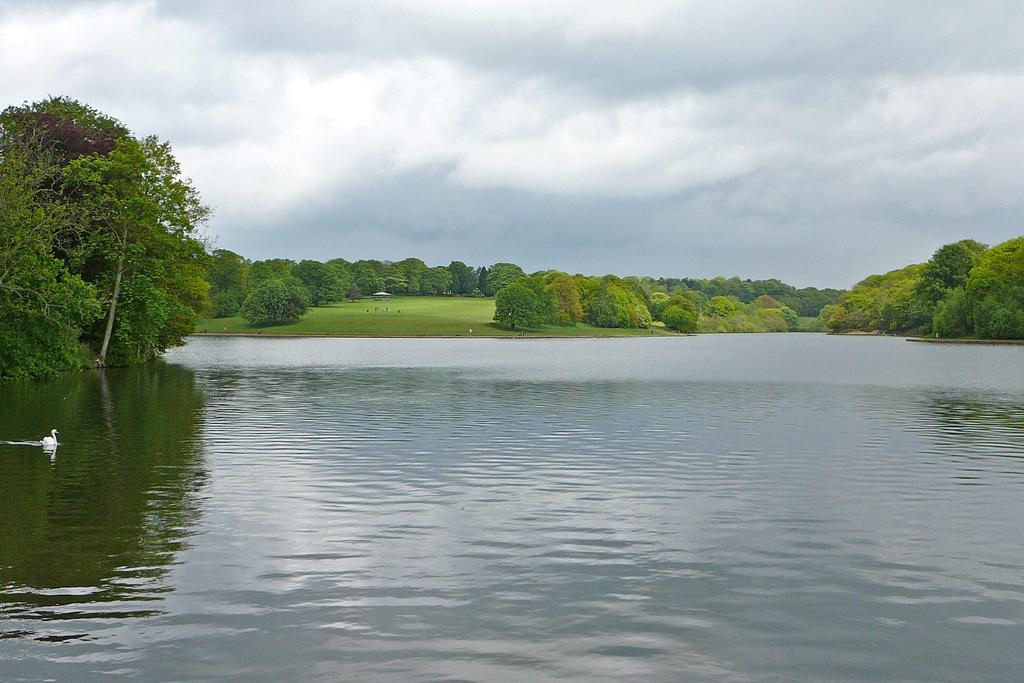What can be seen in the background of the image? In the background of the image, there is sky with clouds, trees, and grass. What is the main subject of the image? The main subject of the image is a swan. What is the swan standing on or near in the image? The swan is visible in the image, and there is water present. What type of boot is being used to generate heat in the image? There is no boot or heat generation present in the image. Is there a bed visible in the image? No, there is no bed visible in the image. 